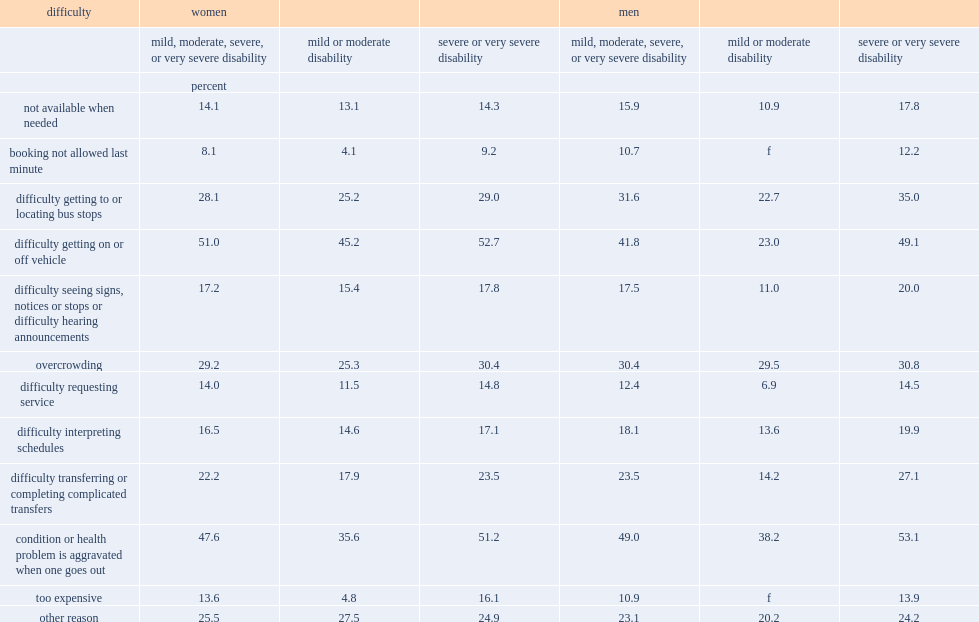For women with disabilities, what was the percentage of women reported to have the difficulty of getting on or off the vehicle? 51.0. For men with disabilities, what was the percentage of women reported to have the difficulty of getting on or off the vehicle? 41.8. What was the proportion of women reported that they felt their condition or health problem was aggravated when they went out? 47.6. What was the proportion of men reported that they felt their condition or health problem was aggravated when they went out? 49.0. What was the proportion of women reported that they felt the transit was overcrowded? 29.2. What was the proportion of men reported that they felt the transit was overcrowded? 30.4. What was the proportion of women reported that they had difficulty getting to or locating bus stops? 28.1. What was the proportion of men reported that they had difficulty getting to or locating bus stops? 31.6. Who were more likely to reported that their condition or health problem was aggravated when they went out ,women with severe or very severe disabilities or women with mild or moderate disabilities? Severe or very severe disability. How many times women with severe or very severe disabilities were more likely than women with mild or moderate disabilities to report having difficulty booking, as it was not allowed last minute? 2.243902. How many times women with severe or very severe disabilities were more likely than women with mild or moderate disabilities to report the transit was too expensive? 3.354167. Who were more likely to reported that their condition or health problem was aggravated when they went out, men with severe or very severe disabilities or men with mild or moderate disabilities? Severe or very severe disability. Who were more likely to reported that they had difficulty getting on or off the vehicle, men with severe or very severe disabilities or men with mild or moderate disabilities? Severe or very severe disability. Who were more likely to reported that they had difficulty getting to or locating bus stops, men with severe or very severe disabilities or men with mild or moderate disabilities? Severe or very severe disability. Who were more likely to reported that they had difficulty transferring or completing complicated transfers, men with severe or very severe disabilities or men with mild or moderate disabilities? Severe or very severe disability. Who were more likely to reported that they had difficulty seeing signs, notices or stops or have difficulty hearing announcements, men with severe or very severe disabilities or men with mild or moderate disabilities? Severe or very severe disability. Who were more likely to reported that they had difficulty srequesting service, men with severe or very severe disabilities or men with mild or moderate disabilities? Severe or very severe disability. 